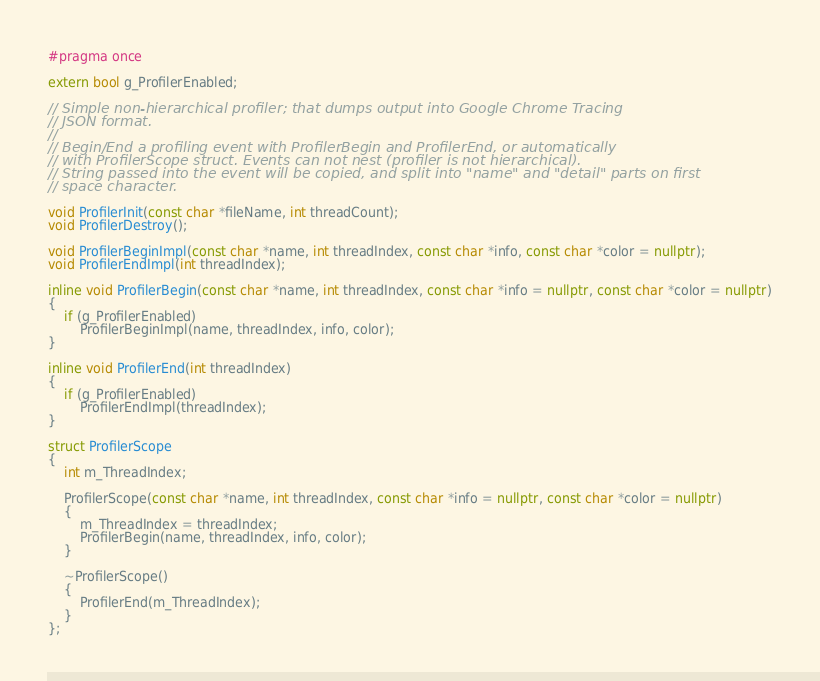<code> <loc_0><loc_0><loc_500><loc_500><_C++_>#pragma once

extern bool g_ProfilerEnabled;

// Simple non-hierarchical profiler; that dumps output into Google Chrome Tracing
// JSON format.
//
// Begin/End a profiling event with ProfilerBegin and ProfilerEnd, or automatically
// with ProfilerScope struct. Events can not nest (profiler is not hierarchical).
// String passed into the event will be copied, and split into "name" and "detail" parts on first
// space character.

void ProfilerInit(const char *fileName, int threadCount);
void ProfilerDestroy();

void ProfilerBeginImpl(const char *name, int threadIndex, const char *info, const char *color = nullptr);
void ProfilerEndImpl(int threadIndex);

inline void ProfilerBegin(const char *name, int threadIndex, const char *info = nullptr, const char *color = nullptr)
{
    if (g_ProfilerEnabled)
        ProfilerBeginImpl(name, threadIndex, info, color);
}

inline void ProfilerEnd(int threadIndex)
{
    if (g_ProfilerEnabled)
        ProfilerEndImpl(threadIndex);
}

struct ProfilerScope
{
    int m_ThreadIndex;

    ProfilerScope(const char *name, int threadIndex, const char *info = nullptr, const char *color = nullptr)
    {
        m_ThreadIndex = threadIndex;
        ProfilerBegin(name, threadIndex, info, color);
    }

    ~ProfilerScope()
    {
        ProfilerEnd(m_ThreadIndex);
    }
};
</code> 